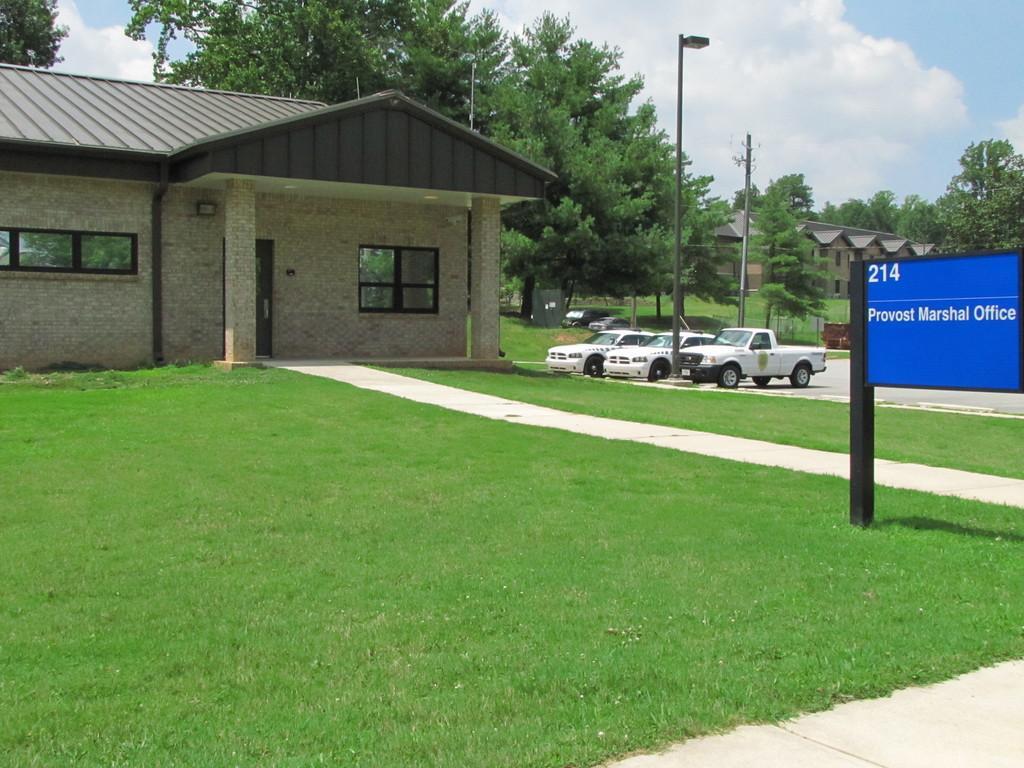In one or two sentences, can you explain what this image depicts? In this image, we can see some houses, trees, poles, vehicles. We can see the ground with grass and some objects. We can also see a board with text. We can see the sky with clouds. 